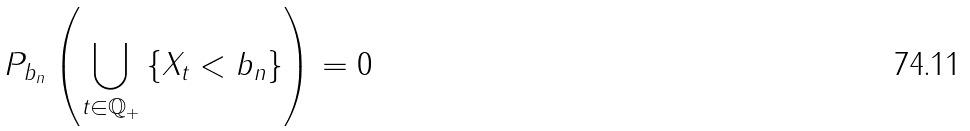<formula> <loc_0><loc_0><loc_500><loc_500>P _ { b _ { n } } \left ( \bigcup _ { t \in \mathbb { Q } _ { + } } \left \{ X _ { t } < b _ { n } \right \} \right ) = 0</formula> 